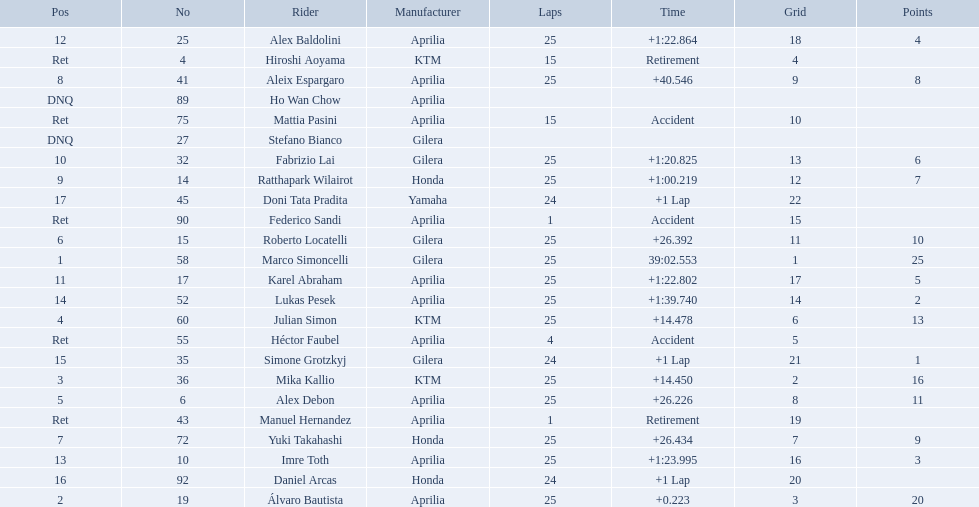Who are all the riders? Marco Simoncelli, Álvaro Bautista, Mika Kallio, Julian Simon, Alex Debon, Roberto Locatelli, Yuki Takahashi, Aleix Espargaro, Ratthapark Wilairot, Fabrizio Lai, Karel Abraham, Alex Baldolini, Imre Toth, Lukas Pesek, Simone Grotzkyj, Daniel Arcas, Doni Tata Pradita, Hiroshi Aoyama, Mattia Pasini, Héctor Faubel, Federico Sandi, Manuel Hernandez, Stefano Bianco, Ho Wan Chow. Which held rank 1? Marco Simoncelli. 